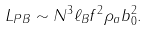<formula> <loc_0><loc_0><loc_500><loc_500>L _ { P B } \sim N ^ { 3 } \ell _ { B } f ^ { 2 } \rho _ { a } b _ { 0 } ^ { 2 } .</formula> 